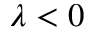Convert formula to latex. <formula><loc_0><loc_0><loc_500><loc_500>\lambda < 0</formula> 